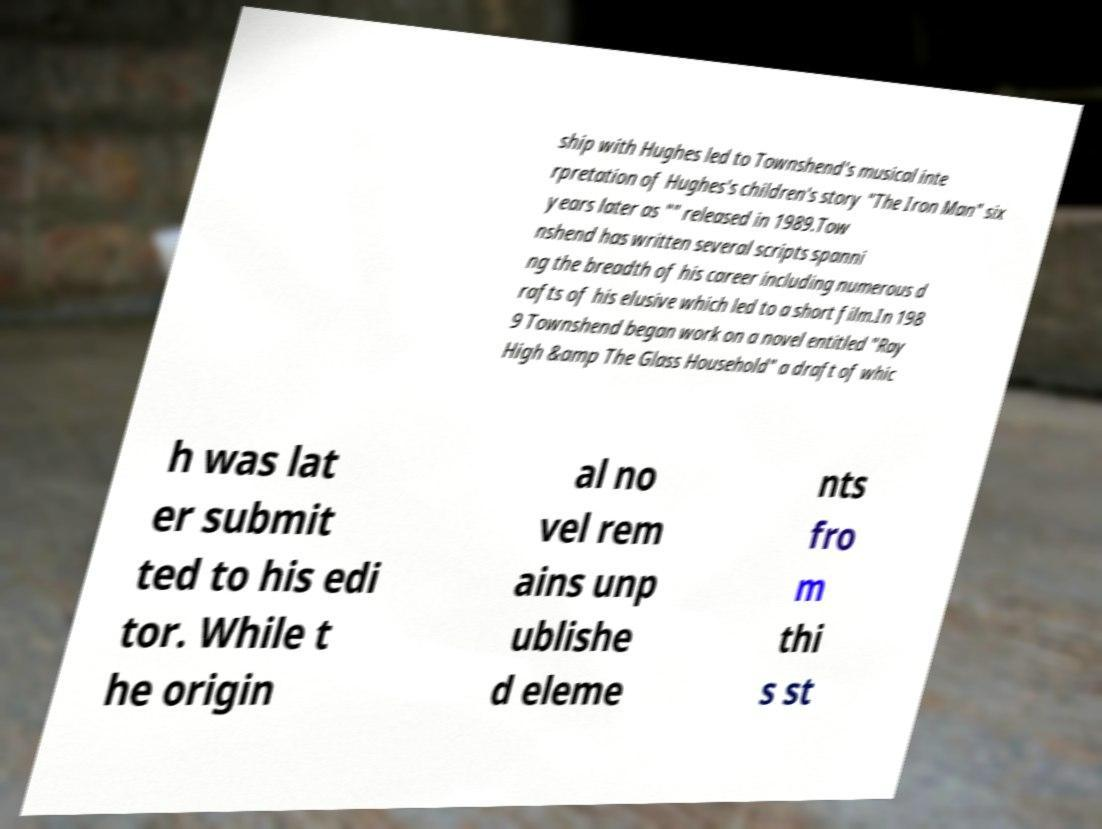There's text embedded in this image that I need extracted. Can you transcribe it verbatim? ship with Hughes led to Townshend's musical inte rpretation of Hughes's children's story "The Iron Man" six years later as "" released in 1989.Tow nshend has written several scripts spanni ng the breadth of his career including numerous d rafts of his elusive which led to a short film.In 198 9 Townshend began work on a novel entitled "Ray High &amp The Glass Household" a draft of whic h was lat er submit ted to his edi tor. While t he origin al no vel rem ains unp ublishe d eleme nts fro m thi s st 